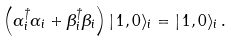Convert formula to latex. <formula><loc_0><loc_0><loc_500><loc_500>\left ( \alpha ^ { \dagger } _ { i } \alpha _ { i } + \beta ^ { \dagger } _ { i } \beta _ { i } \right ) | \, 1 , 0 \rangle _ { i } = | \, 1 , 0 \rangle _ { i } \, .</formula> 